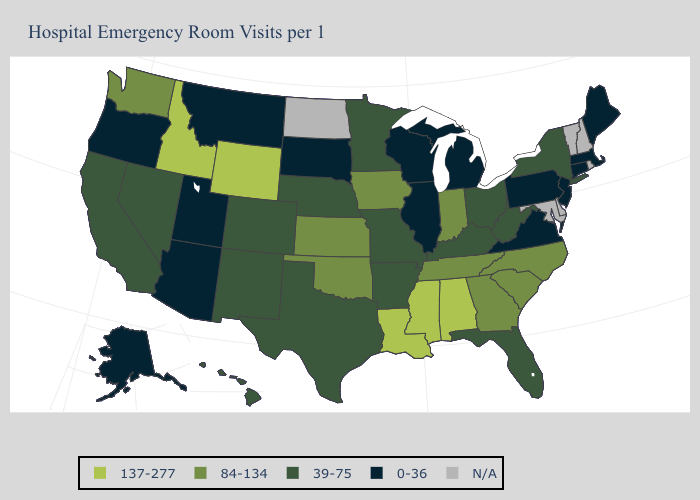What is the value of Nebraska?
Answer briefly. 39-75. Name the states that have a value in the range 84-134?
Short answer required. Georgia, Indiana, Iowa, Kansas, North Carolina, Oklahoma, South Carolina, Tennessee, Washington. Among the states that border Florida , does Alabama have the highest value?
Answer briefly. Yes. Does the first symbol in the legend represent the smallest category?
Concise answer only. No. What is the value of Wisconsin?
Be succinct. 0-36. Among the states that border North Carolina , does South Carolina have the highest value?
Quick response, please. Yes. What is the highest value in the USA?
Concise answer only. 137-277. What is the highest value in the USA?
Concise answer only. 137-277. Which states have the lowest value in the MidWest?
Short answer required. Illinois, Michigan, South Dakota, Wisconsin. What is the value of California?
Short answer required. 39-75. Does the first symbol in the legend represent the smallest category?
Concise answer only. No. Name the states that have a value in the range 0-36?
Concise answer only. Alaska, Arizona, Connecticut, Illinois, Maine, Massachusetts, Michigan, Montana, New Jersey, Oregon, Pennsylvania, South Dakota, Utah, Virginia, Wisconsin. Does Arkansas have the highest value in the South?
Give a very brief answer. No. 